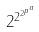<formula> <loc_0><loc_0><loc_500><loc_500>2 ^ { 2 ^ { 2 ^ { p ^ { a } } } }</formula> 